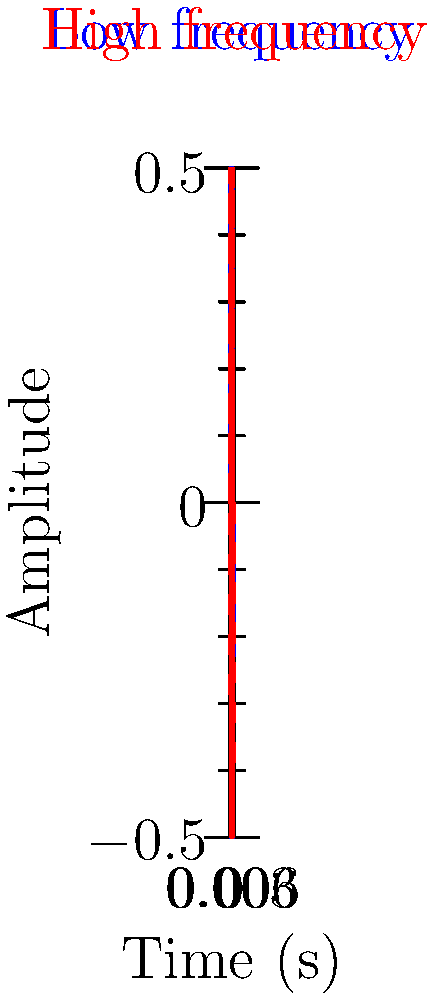In Taylor Swift's song "Shake It Off", the chorus features a catchy high-pitched "oh-oh-oh" backing vocal. If this high-pitched sound has a frequency of 1000 Hz, and the lower-pitched main vocal has a frequency of 500 Hz, what is the ratio of their wavelengths? Assume the speed of sound in air is 343 m/s. Use the waveform diagram above to visualize the difference in frequency between these two sounds. To solve this problem, let's follow these steps:

1. Recall the relationship between wavelength ($\lambda$), frequency ($f$), and speed of sound ($v$):
   $v = f \lambda$

2. For the high-pitched backing vocal:
   $343 = 1000 \lambda_h$
   $\lambda_h = 343 / 1000 = 0.343$ m

3. For the lower-pitched main vocal:
   $343 = 500 \lambda_l$
   $\lambda_l = 343 / 500 = 0.686$ m

4. The ratio of wavelengths is:
   $\frac{\lambda_l}{\lambda_h} = \frac{0.686}{0.343} = 2$

5. We can also derive this directly from the frequencies:
   $\frac{\lambda_l}{\lambda_h} = \frac{f_h}{f_l} = \frac{1000}{500} = 2$

This ratio means that the wavelength of the lower-pitched main vocal is twice that of the higher-pitched backing vocal, which is consistent with the waveform diagram where the red dashed line (high frequency) completes two cycles for every one cycle of the blue line (low frequency).
Answer: 2:1 